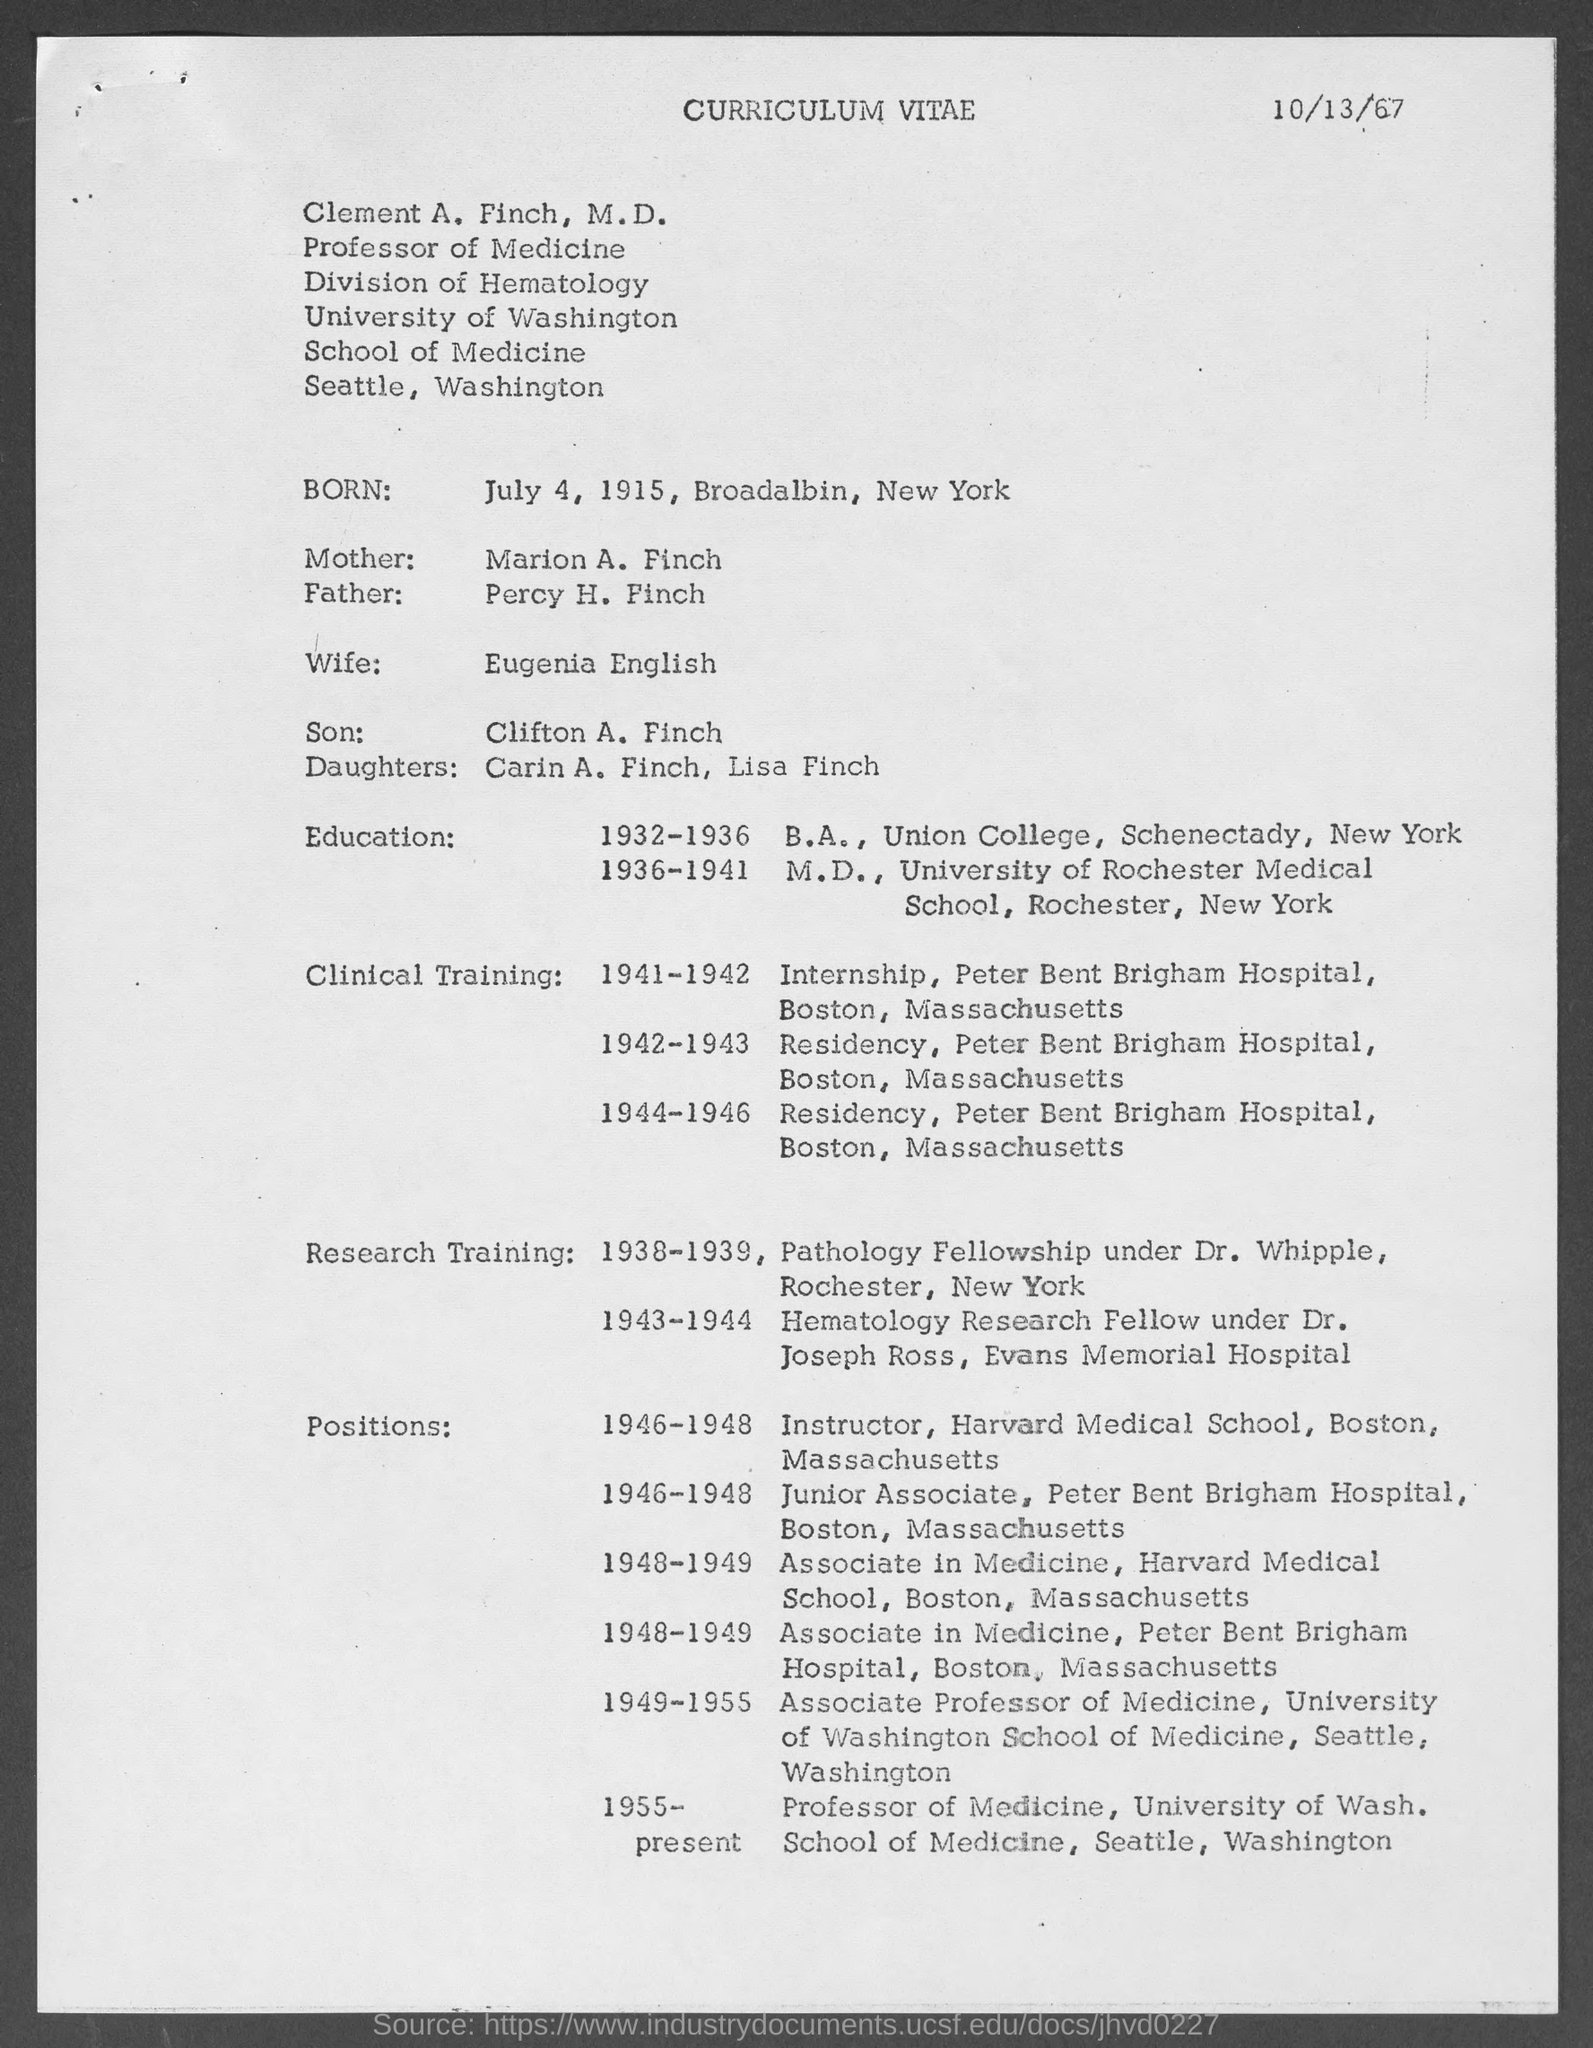When is the document dated?
Your answer should be very brief. 10/13/67. What is the designation of Clement A. Finch?
Your answer should be very brief. Professor of Medicine. When was Clement born?
Offer a terse response. July 4, 1915. Who is Clement married to?
Make the answer very short. Eugenia English. What is Clement's son's name?
Your answer should be very brief. Clifton A. Finch. In which year did Clement do his internship?
Your answer should be compact. 1941-1942. 